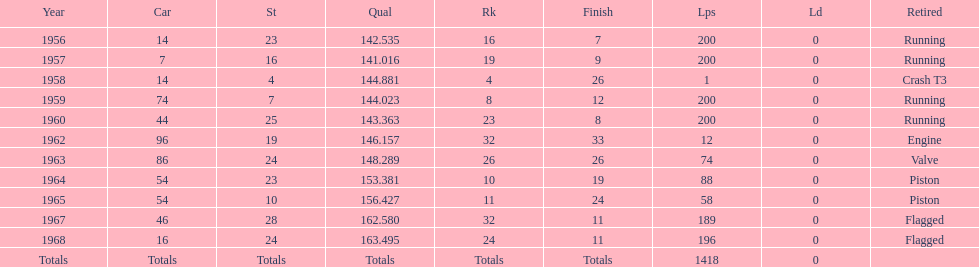How many times was bob veith ranked higher than 10 at an indy 500? 2. Would you mind parsing the complete table? {'header': ['Year', 'Car', 'St', 'Qual', 'Rk', 'Finish', 'Lps', 'Ld', 'Retired'], 'rows': [['1956', '14', '23', '142.535', '16', '7', '200', '0', 'Running'], ['1957', '7', '16', '141.016', '19', '9', '200', '0', 'Running'], ['1958', '14', '4', '144.881', '4', '26', '1', '0', 'Crash T3'], ['1959', '74', '7', '144.023', '8', '12', '200', '0', 'Running'], ['1960', '44', '25', '143.363', '23', '8', '200', '0', 'Running'], ['1962', '96', '19', '146.157', '32', '33', '12', '0', 'Engine'], ['1963', '86', '24', '148.289', '26', '26', '74', '0', 'Valve'], ['1964', '54', '23', '153.381', '10', '19', '88', '0', 'Piston'], ['1965', '54', '10', '156.427', '11', '24', '58', '0', 'Piston'], ['1967', '46', '28', '162.580', '32', '11', '189', '0', 'Flagged'], ['1968', '16', '24', '163.495', '24', '11', '196', '0', 'Flagged'], ['Totals', 'Totals', 'Totals', 'Totals', 'Totals', 'Totals', '1418', '0', '']]} 